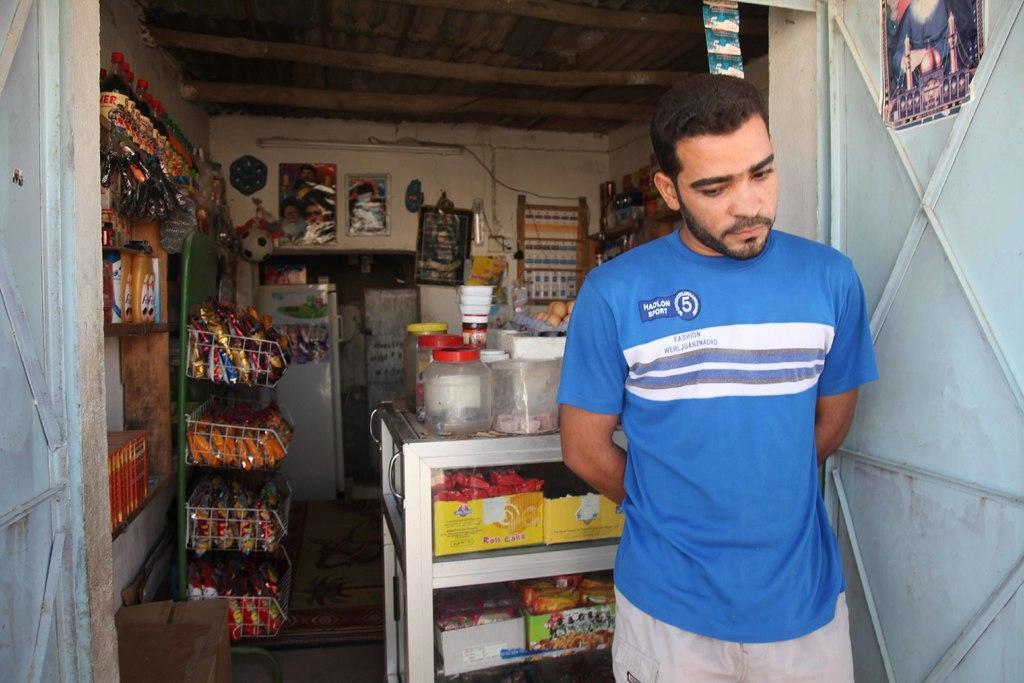In one or two sentences, can you explain what this image depicts? In this image we can see a person standing beside a gate. We can also see a picture pasted on a gate. On the backside we can see some covers in the racks, bottles and boxes in the shelves, a refrigerator and a table containing some containers on it. We can also see some pictures, a clock and a tube light on a wall. 